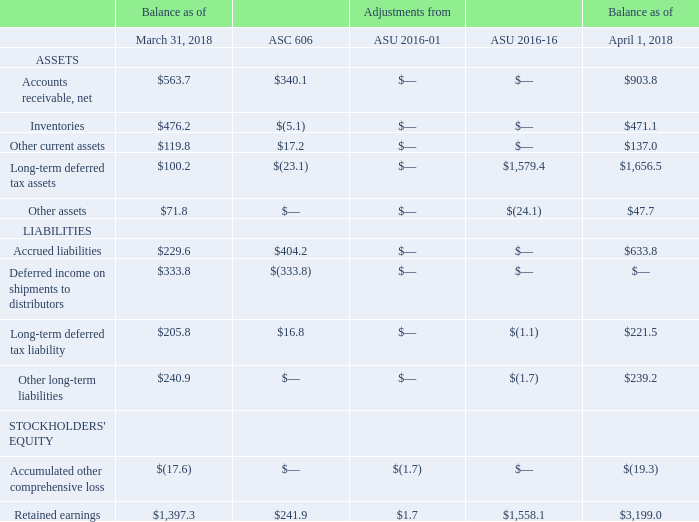During the three months ended June 30, 2018, the Company adopted ASU 2016-18-Statement of Cash Flows: Restricted Cash. This standard requires that the statement of cash flows explain the change during the period in total cash, cash equivalents, and amounts generally described as restricted cash or restricted cash equivalents. Therefore, amounts generally described as restricted cash and restricted cash equivalents should be included with cash and cash equivalents when reconciling the beginning-of-period and end-of-period total amounts shown on the statement of cash flows. The standard has been applied using a retrospective transition method to each period presented. The adoption of this standard did not have a material impact on the Company's financial statements.
The following table summarizes the opening balance sheet adjustments related to the adoption of the New Revenue Standard, ASU 2016-01-Financial Instruments - Overall (Subtopic 825-10): Recognition and Measurement of Financial Assets and Financial Liabilities, and ASU 2016-16-Intra-Entity Transfers of Assets Other Than Inventory (in millions):
What was the balance of net accounts receivable on March 31, 2018?
Answer scale should be: million. 563.7. What was the balance of Inventories on April 1, 2018?
Answer scale should be: million. 471.1. What was the adjustment from ASC 606 for other current assets?
Answer scale should be: million. 17.2. How many liabilities had a balance on March 31, 2018 that exceeded $300 million? Deferred income on shipments to distributors
Answer: 1. How many Assets had a balance on April 1, 2018 that exceeded $1,000 million? Long-term deferred tax assets
Answer: 1. What was the percentage change in Other assets due to the adjustments?
Answer scale should be: percent. (47.7-71.8)/71.8
Answer: -33.57. 